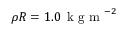Convert formula to latex. <formula><loc_0><loc_0><loc_500><loc_500>\rho R = 1 . 0 \, k g m ^ { - 2 }</formula> 